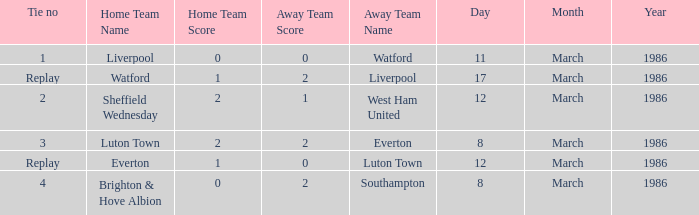Who was the home team in the match against Luton Town? Everton. 